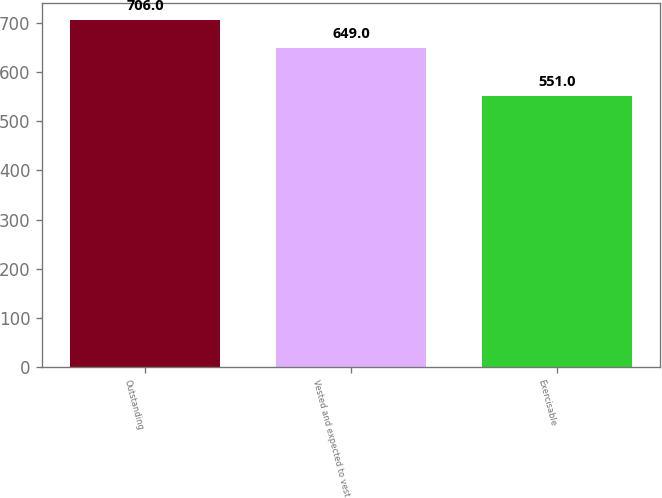Convert chart to OTSL. <chart><loc_0><loc_0><loc_500><loc_500><bar_chart><fcel>Outstanding<fcel>Vested and expected to vest<fcel>Exercisable<nl><fcel>706<fcel>649<fcel>551<nl></chart> 